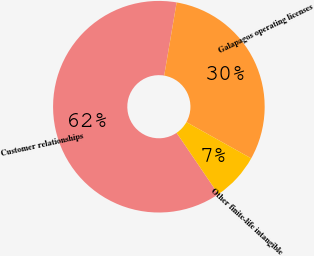Convert chart. <chart><loc_0><loc_0><loc_500><loc_500><pie_chart><fcel>Customer relationships<fcel>Galapagos operating licenses<fcel>Other finite-life intangible<nl><fcel>62.19%<fcel>30.43%<fcel>7.38%<nl></chart> 